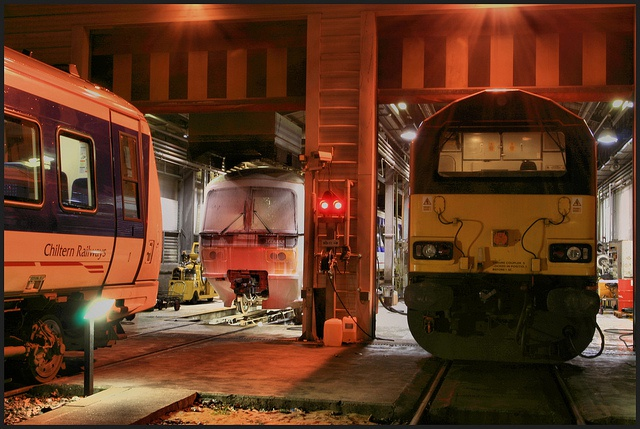Describe the objects in this image and their specific colors. I can see train in black, brown, and maroon tones, train in black, maroon, red, and salmon tones, and train in black, brown, and maroon tones in this image. 